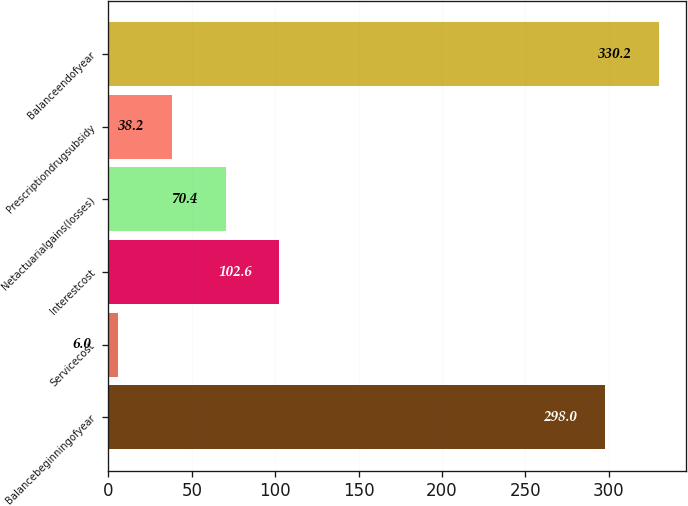Convert chart. <chart><loc_0><loc_0><loc_500><loc_500><bar_chart><fcel>Balancebeginningofyear<fcel>Servicecost<fcel>Interestcost<fcel>Netactuarialgains(losses)<fcel>Prescriptiondrugsubsidy<fcel>Balanceendofyear<nl><fcel>298<fcel>6<fcel>102.6<fcel>70.4<fcel>38.2<fcel>330.2<nl></chart> 